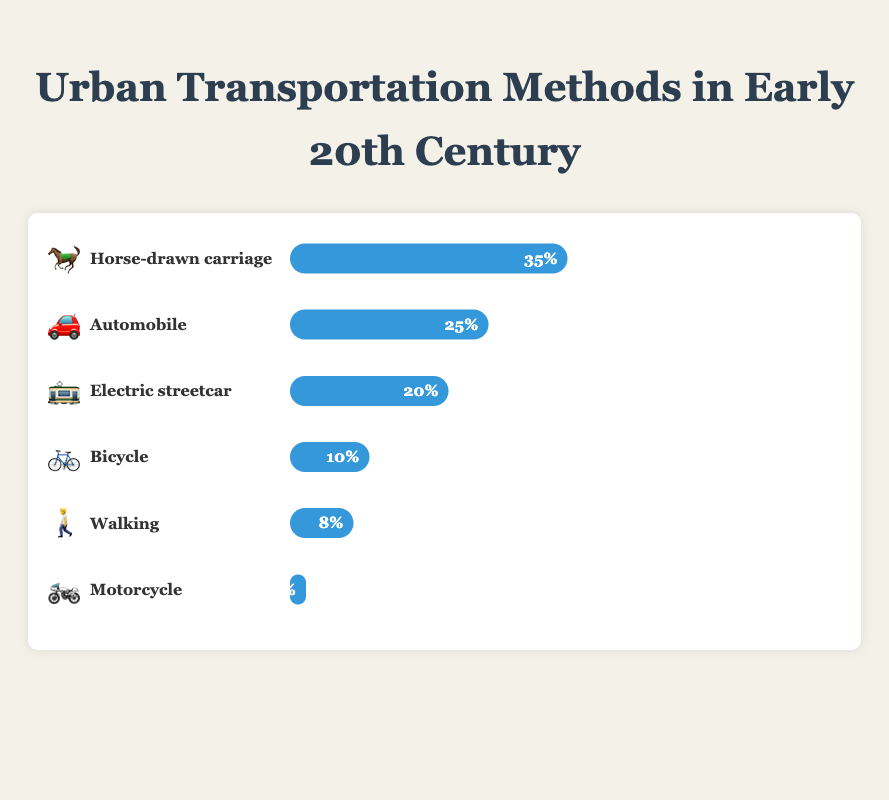Which transportation method was the most popular among urban businesspeople in the early 20th century? The method with the largest percentage bar and the most prominent emoji represents the most popular transportation method. The "Horse-drawn carriage" with an emoji 🐎 takes up 35% of the chart, which is the highest among all methods.
Answer: Horse-drawn carriage Which two transportation methods combined account for more than half of the transportation methods used? Summing up the percentages of transportation methods to find those that together exceed 50%. "Horse-drawn carriage" (35%) combined with "Automobile" (25%) results in a total of 60%, which is more than half.
Answer: Horse-drawn carriage and Automobile How much more popular was the Horse-drawn carriage compared to Walking? The difference in percentages between Horse-drawn carriage (35%) and Walking (8%) is calculated by subtracting the smaller percentage from the larger one. 35% - 8% = 27%.
Answer: 27% Which transportation methods have a usage percentage of 10% or less? Identify the methods with percentage bars labeled 10% or less. "Bicycle" (10%), "Walking" (8%), and "Motorcycle" (2%) all fall into this category.
Answer: Bicycle, Walking, Motorcycle If we were to combine all public transportation methods, what would their total percentage be? Add the percentages of public transportation methods: "Electric streetcar" (20%) and "Walking" (8%). 20% + 8% = 28%.
Answer: 28% What is the second least popular transportation method and its percentage? Find the method with the second smallest percentage bar. "Walking" (8%) is larger only than "Motorcycle" (2%), making it the second least popular.
Answer: Walking, 8% How much more popular was the Electric streetcar compared to the Bicycle? The difference in percentages between Electric streetcar (20%) and Bicycle (10%) is 20% - 10% = 10%.
Answer: 10% List the transportation methods in descending order of popularity. Arrange the methods by their given percentages in descending order: Horse-drawn carriage (35%), Automobile (25%), Electric streetcar (20%), Bicycle (10%), Walking (8%), Motorcycle (2%).
Answer: Horse-drawn carriage, Automobile, Electric streetcar, Bicycle, Walking, Motorcycle What percentage of urban businesspeople relied on non-motorized transportation methods? Add the percentages of non-motorized methods: "Horse-drawn carriage" (35%), "Bicycle" (10%), and "Walking" (8%). 35% + 10% + 8% = 53%.
Answer: 53% Which transportation method represents the smallest slice of the chart? The method with the smallest percentage bar indicates the smallest slice. "Motorcycle" with 2% falls into this category.
Answer: Motorcycle 